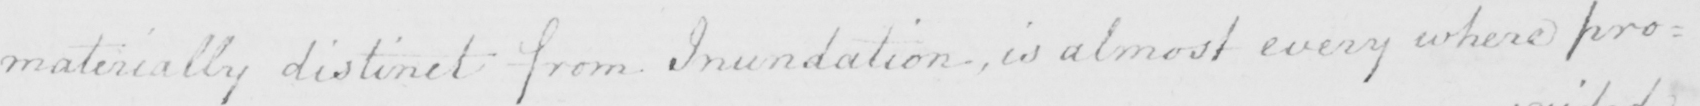Please transcribe the handwritten text in this image. materially distinct from Inundation , is almost every where pro= 